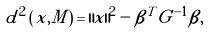Convert formula to latex. <formula><loc_0><loc_0><loc_500><loc_500>d ^ { 2 } \left ( x , M \right ) = \left \| x \right \| ^ { 2 } - \beta ^ { T } G ^ { - 1 } \beta ,</formula> 